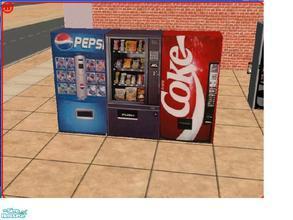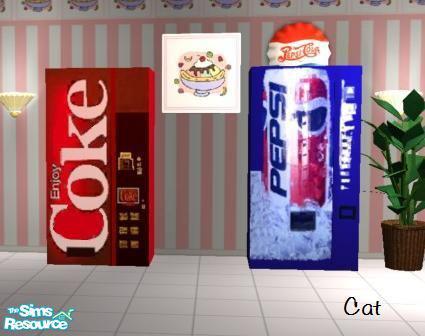The first image is the image on the left, the second image is the image on the right. Given the left and right images, does the statement "Exactly five vending machines are depicted." hold true? Answer yes or no. Yes. The first image is the image on the left, the second image is the image on the right. Given the left and right images, does the statement "Multiple vending machines are displayed in front of a wall of graffiti, in one image." hold true? Answer yes or no. No. 